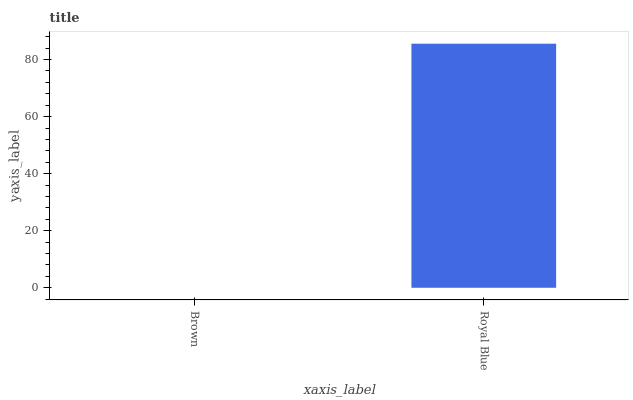Is Royal Blue the minimum?
Answer yes or no. No. Is Royal Blue greater than Brown?
Answer yes or no. Yes. Is Brown less than Royal Blue?
Answer yes or no. Yes. Is Brown greater than Royal Blue?
Answer yes or no. No. Is Royal Blue less than Brown?
Answer yes or no. No. Is Royal Blue the high median?
Answer yes or no. Yes. Is Brown the low median?
Answer yes or no. Yes. Is Brown the high median?
Answer yes or no. No. Is Royal Blue the low median?
Answer yes or no. No. 